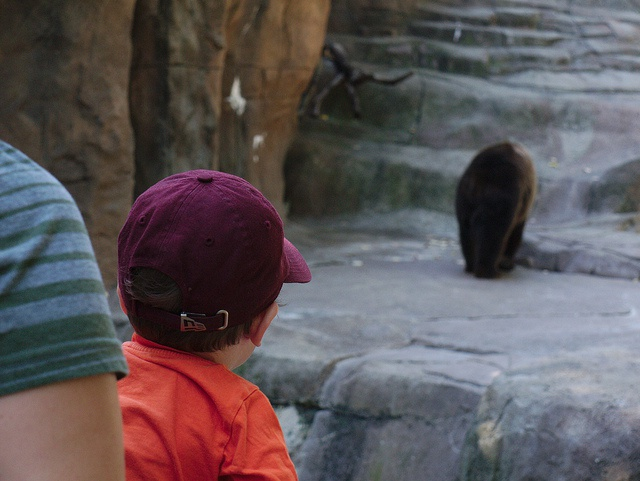Describe the objects in this image and their specific colors. I can see people in black, brown, maroon, and red tones, people in black, gray, and purple tones, and bear in black and gray tones in this image. 